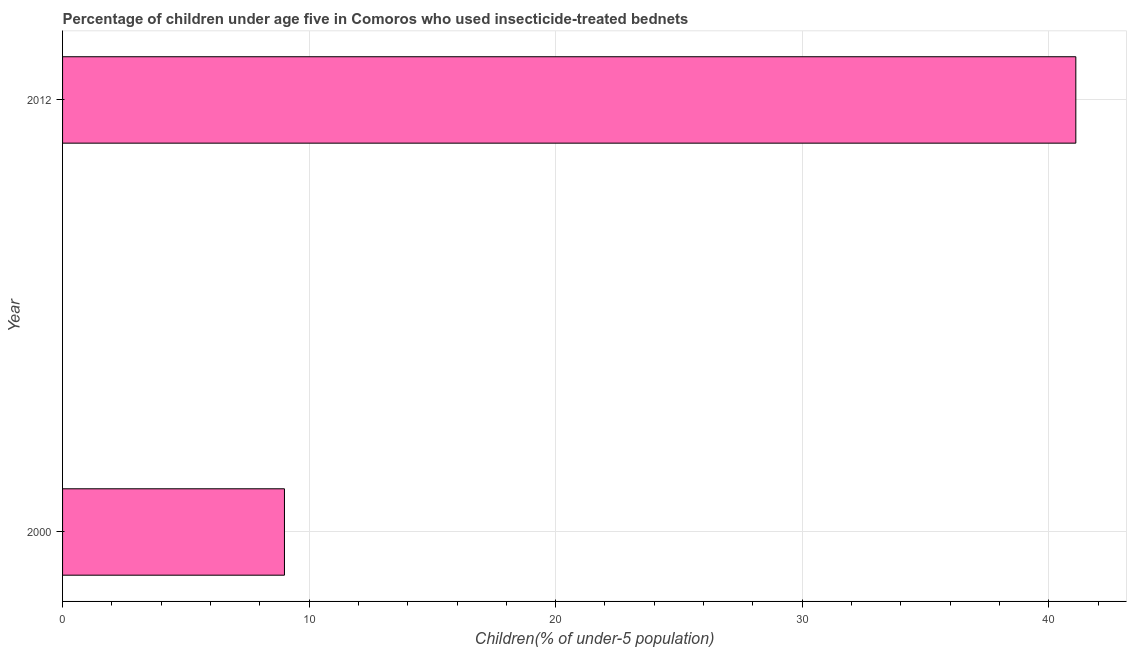What is the title of the graph?
Make the answer very short. Percentage of children under age five in Comoros who used insecticide-treated bednets. What is the label or title of the X-axis?
Your answer should be compact. Children(% of under-5 population). What is the label or title of the Y-axis?
Your answer should be very brief. Year. What is the percentage of children who use of insecticide-treated bed nets in 2000?
Your answer should be very brief. 9. Across all years, what is the maximum percentage of children who use of insecticide-treated bed nets?
Give a very brief answer. 41.1. In which year was the percentage of children who use of insecticide-treated bed nets minimum?
Your answer should be compact. 2000. What is the sum of the percentage of children who use of insecticide-treated bed nets?
Your response must be concise. 50.1. What is the difference between the percentage of children who use of insecticide-treated bed nets in 2000 and 2012?
Offer a very short reply. -32.1. What is the average percentage of children who use of insecticide-treated bed nets per year?
Provide a short and direct response. 25.05. What is the median percentage of children who use of insecticide-treated bed nets?
Your answer should be compact. 25.05. In how many years, is the percentage of children who use of insecticide-treated bed nets greater than 4 %?
Give a very brief answer. 2. What is the ratio of the percentage of children who use of insecticide-treated bed nets in 2000 to that in 2012?
Your answer should be very brief. 0.22. Is the percentage of children who use of insecticide-treated bed nets in 2000 less than that in 2012?
Keep it short and to the point. Yes. How many years are there in the graph?
Provide a succinct answer. 2. What is the Children(% of under-5 population) in 2012?
Keep it short and to the point. 41.1. What is the difference between the Children(% of under-5 population) in 2000 and 2012?
Keep it short and to the point. -32.1. What is the ratio of the Children(% of under-5 population) in 2000 to that in 2012?
Provide a succinct answer. 0.22. 